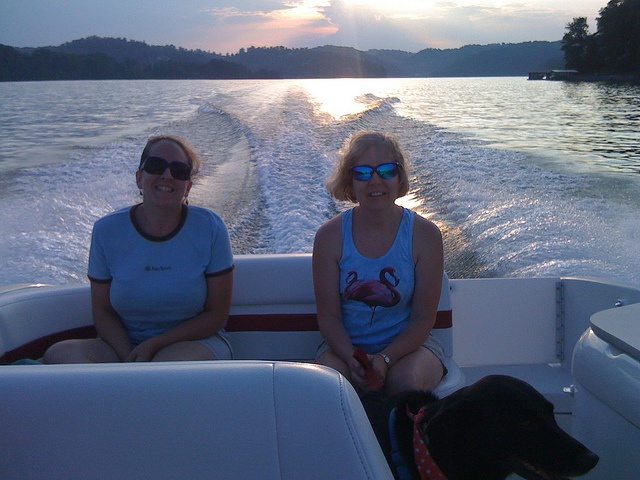Describe the objects in this image and their specific colors. I can see boat in gray, darkblue, blue, and navy tones, people in gray, black, navy, and blue tones, people in gray, navy, black, and darkblue tones, and dog in gray, black, navy, darkblue, and blue tones in this image. 